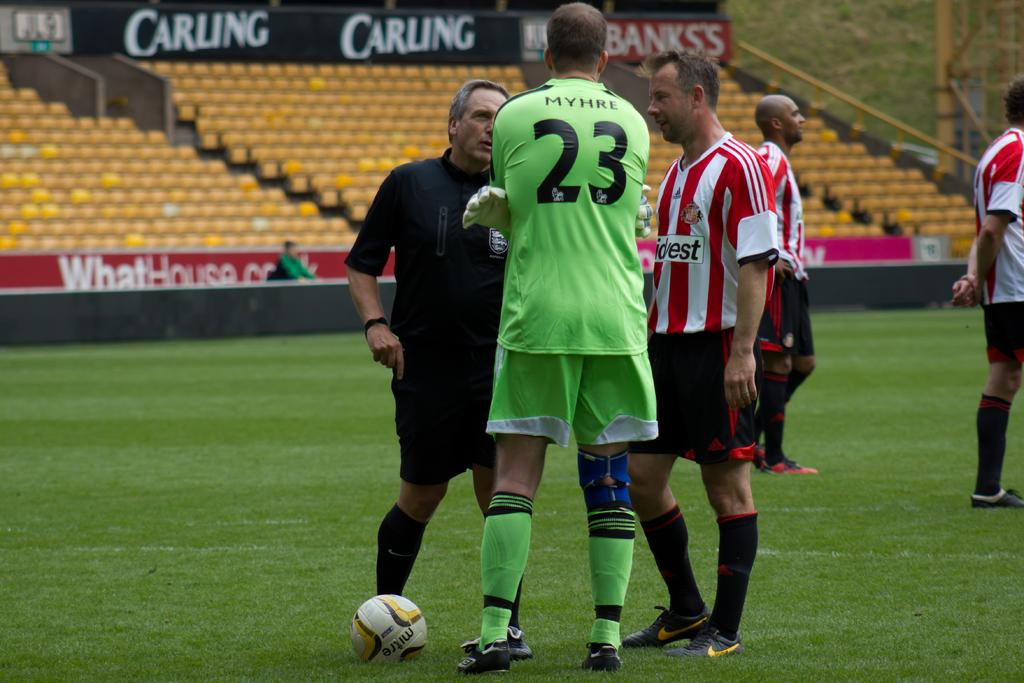<image>
Share a concise interpretation of the image provided. Myhre, number 23 is the name and number on the back of this player's jersey. 